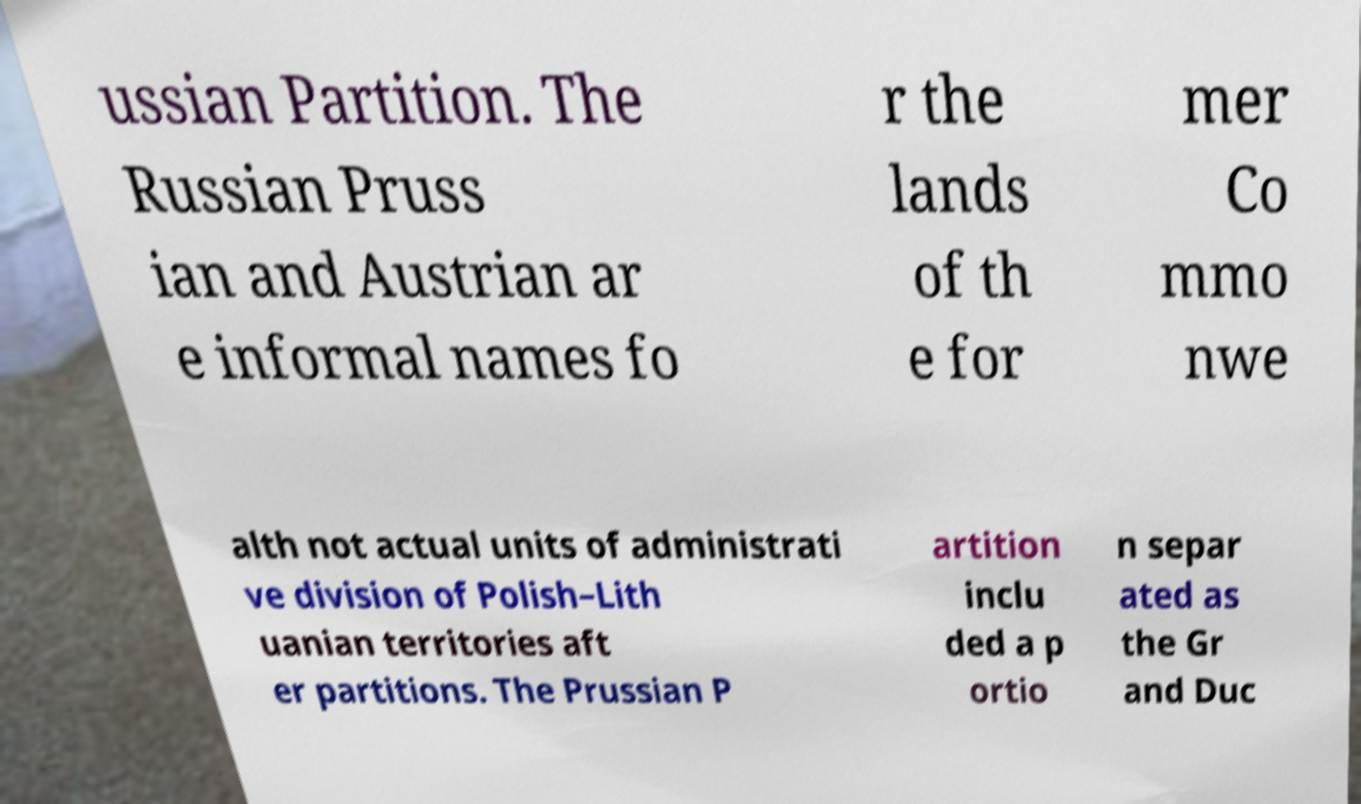For documentation purposes, I need the text within this image transcribed. Could you provide that? ussian Partition. The Russian Pruss ian and Austrian ar e informal names fo r the lands of th e for mer Co mmo nwe alth not actual units of administrati ve division of Polish–Lith uanian territories aft er partitions. The Prussian P artition inclu ded a p ortio n separ ated as the Gr and Duc 